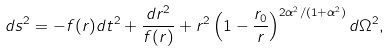<formula> <loc_0><loc_0><loc_500><loc_500>d s ^ { 2 } = - f ( r ) d t ^ { 2 } + \frac { d r ^ { 2 } } { f ( r ) } + r ^ { 2 } \left ( 1 - \frac { r _ { 0 } } { r } \right ) ^ { 2 \alpha ^ { 2 } / ( 1 + \alpha ^ { 2 } ) } d \Omega ^ { 2 } ,</formula> 